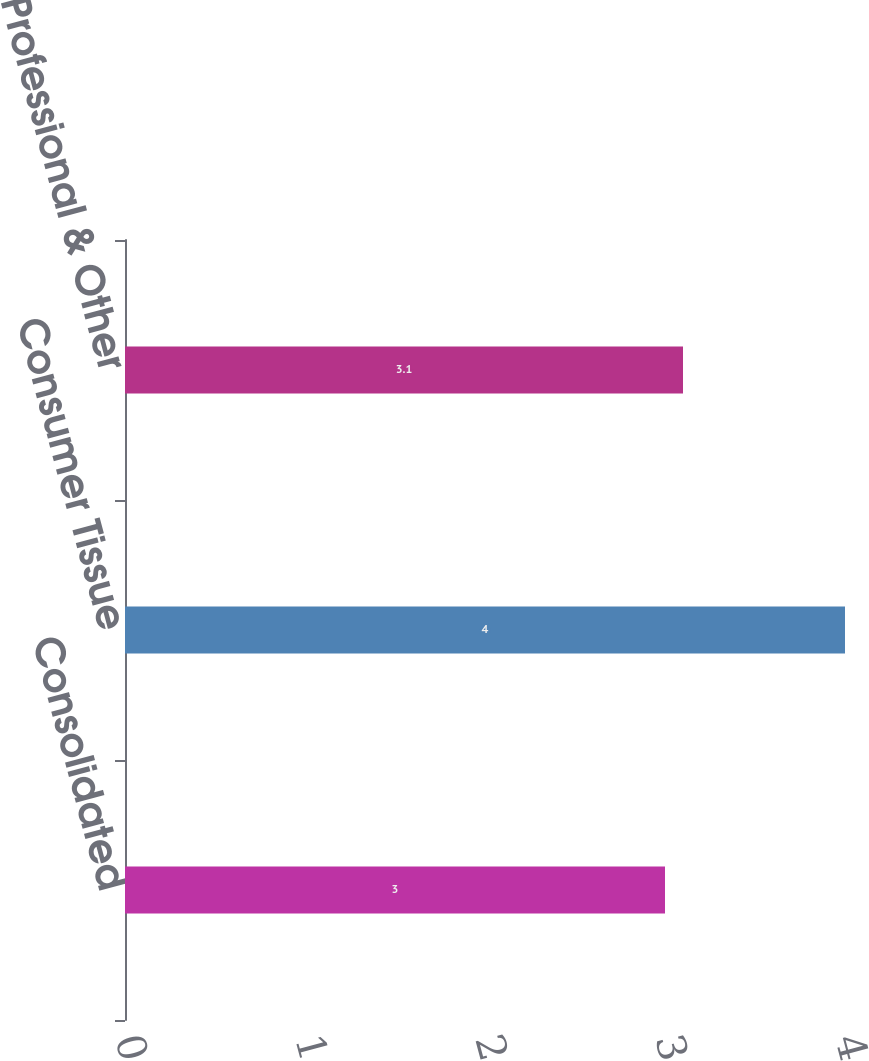<chart> <loc_0><loc_0><loc_500><loc_500><bar_chart><fcel>Consolidated<fcel>Consumer Tissue<fcel>K-C Professional & Other<nl><fcel>3<fcel>4<fcel>3.1<nl></chart> 